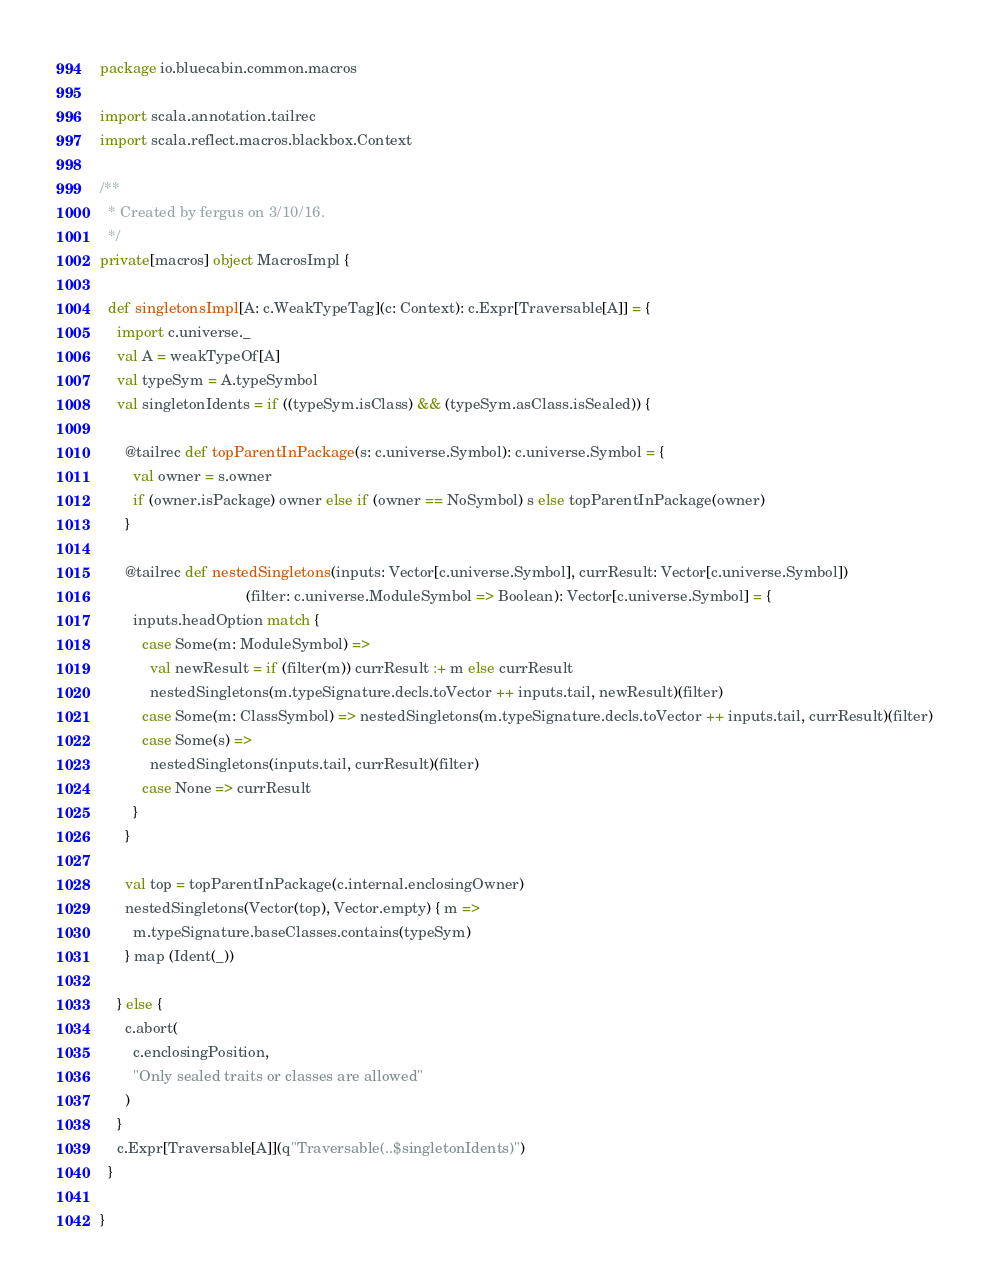<code> <loc_0><loc_0><loc_500><loc_500><_Scala_>package io.bluecabin.common.macros

import scala.annotation.tailrec
import scala.reflect.macros.blackbox.Context

/**
  * Created by fergus on 3/10/16.
  */
private[macros] object MacrosImpl {

  def singletonsImpl[A: c.WeakTypeTag](c: Context): c.Expr[Traversable[A]] = {
    import c.universe._
    val A = weakTypeOf[A]
    val typeSym = A.typeSymbol
    val singletonIdents = if ((typeSym.isClass) && (typeSym.asClass.isSealed)) {

      @tailrec def topParentInPackage(s: c.universe.Symbol): c.universe.Symbol = {
        val owner = s.owner
        if (owner.isPackage) owner else if (owner == NoSymbol) s else topParentInPackage(owner)
      }

      @tailrec def nestedSingletons(inputs: Vector[c.universe.Symbol], currResult: Vector[c.universe.Symbol])
                                   (filter: c.universe.ModuleSymbol => Boolean): Vector[c.universe.Symbol] = {
        inputs.headOption match {
          case Some(m: ModuleSymbol) =>
            val newResult = if (filter(m)) currResult :+ m else currResult
            nestedSingletons(m.typeSignature.decls.toVector ++ inputs.tail, newResult)(filter)
          case Some(m: ClassSymbol) => nestedSingletons(m.typeSignature.decls.toVector ++ inputs.tail, currResult)(filter)
          case Some(s) =>
            nestedSingletons(inputs.tail, currResult)(filter)
          case None => currResult
        }
      }

      val top = topParentInPackage(c.internal.enclosingOwner)
      nestedSingletons(Vector(top), Vector.empty) { m =>
        m.typeSignature.baseClasses.contains(typeSym)
      } map (Ident(_))

    } else {
      c.abort(
        c.enclosingPosition,
        "Only sealed traits or classes are allowed"
      )
    }
    c.Expr[Traversable[A]](q"Traversable(..$singletonIdents)")
  }

}</code> 